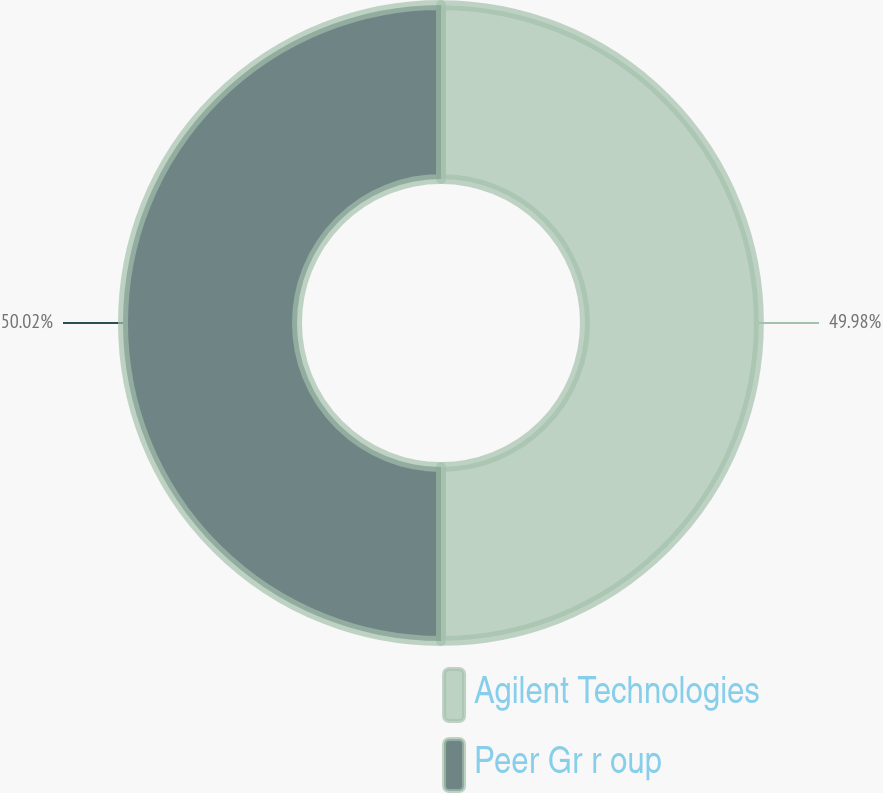Convert chart. <chart><loc_0><loc_0><loc_500><loc_500><pie_chart><fcel>Agilent Technologies<fcel>Peer Gr r oup<nl><fcel>49.98%<fcel>50.02%<nl></chart> 